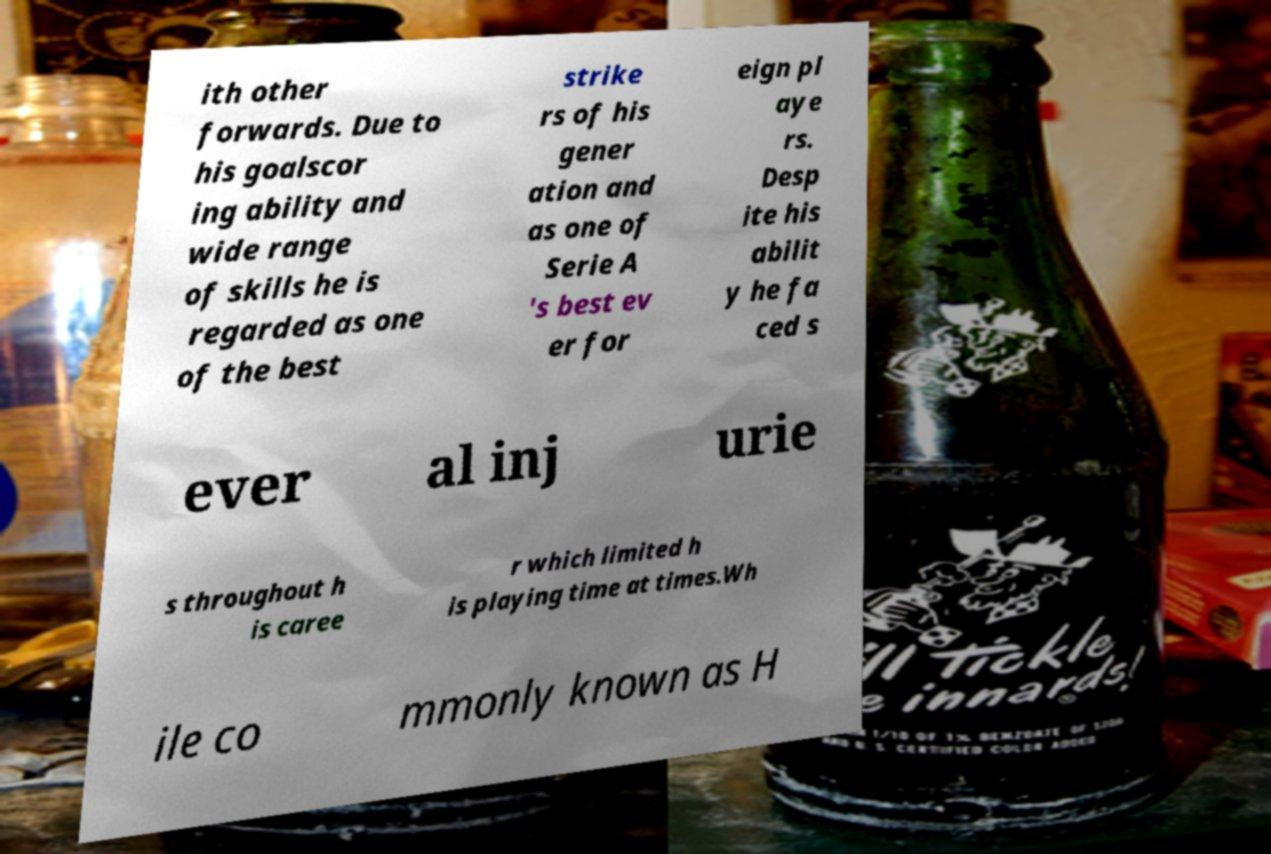What messages or text are displayed in this image? I need them in a readable, typed format. ith other forwards. Due to his goalscor ing ability and wide range of skills he is regarded as one of the best strike rs of his gener ation and as one of Serie A 's best ev er for eign pl aye rs. Desp ite his abilit y he fa ced s ever al inj urie s throughout h is caree r which limited h is playing time at times.Wh ile co mmonly known as H 